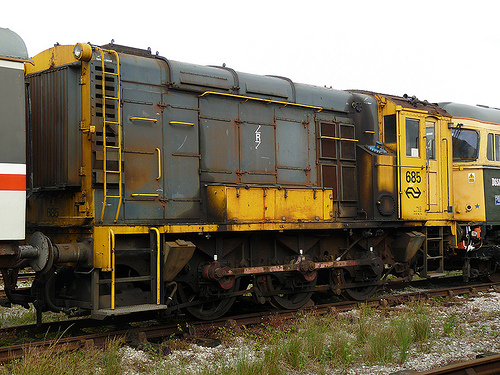Can you see any numbers or letters on the vehicles? If yes, what are they? Yes, I can see the number '685' on the yellow and gray train car. 